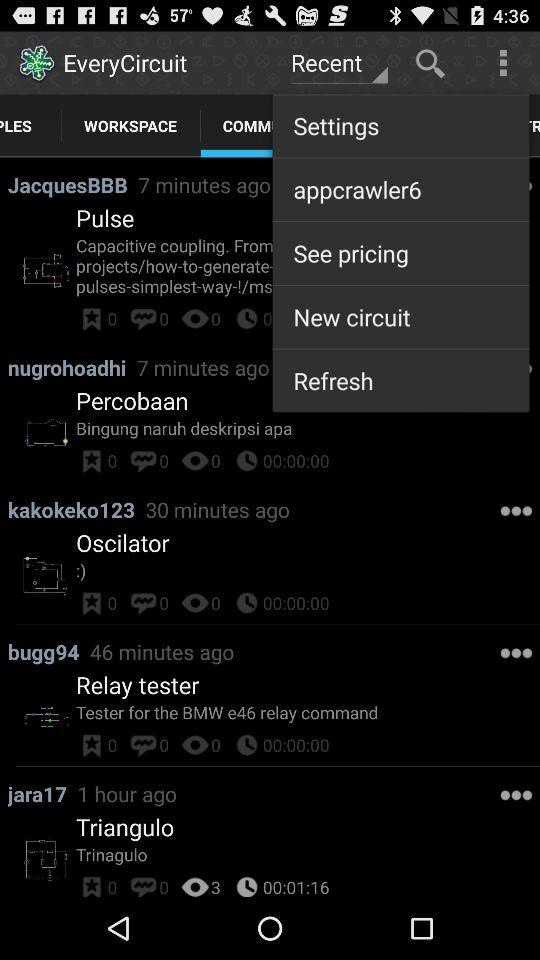When did "bugg94" post the post? "bugg94" posted the post 46 minutes ago. 